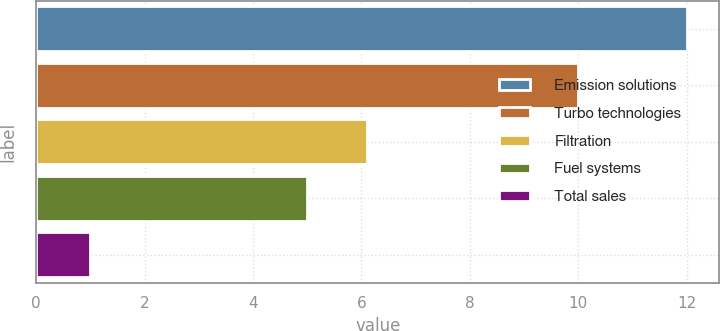<chart> <loc_0><loc_0><loc_500><loc_500><bar_chart><fcel>Emission solutions<fcel>Turbo technologies<fcel>Filtration<fcel>Fuel systems<fcel>Total sales<nl><fcel>12<fcel>10<fcel>6.1<fcel>5<fcel>1<nl></chart> 